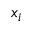Convert formula to latex. <formula><loc_0><loc_0><loc_500><loc_500>x _ { i }</formula> 